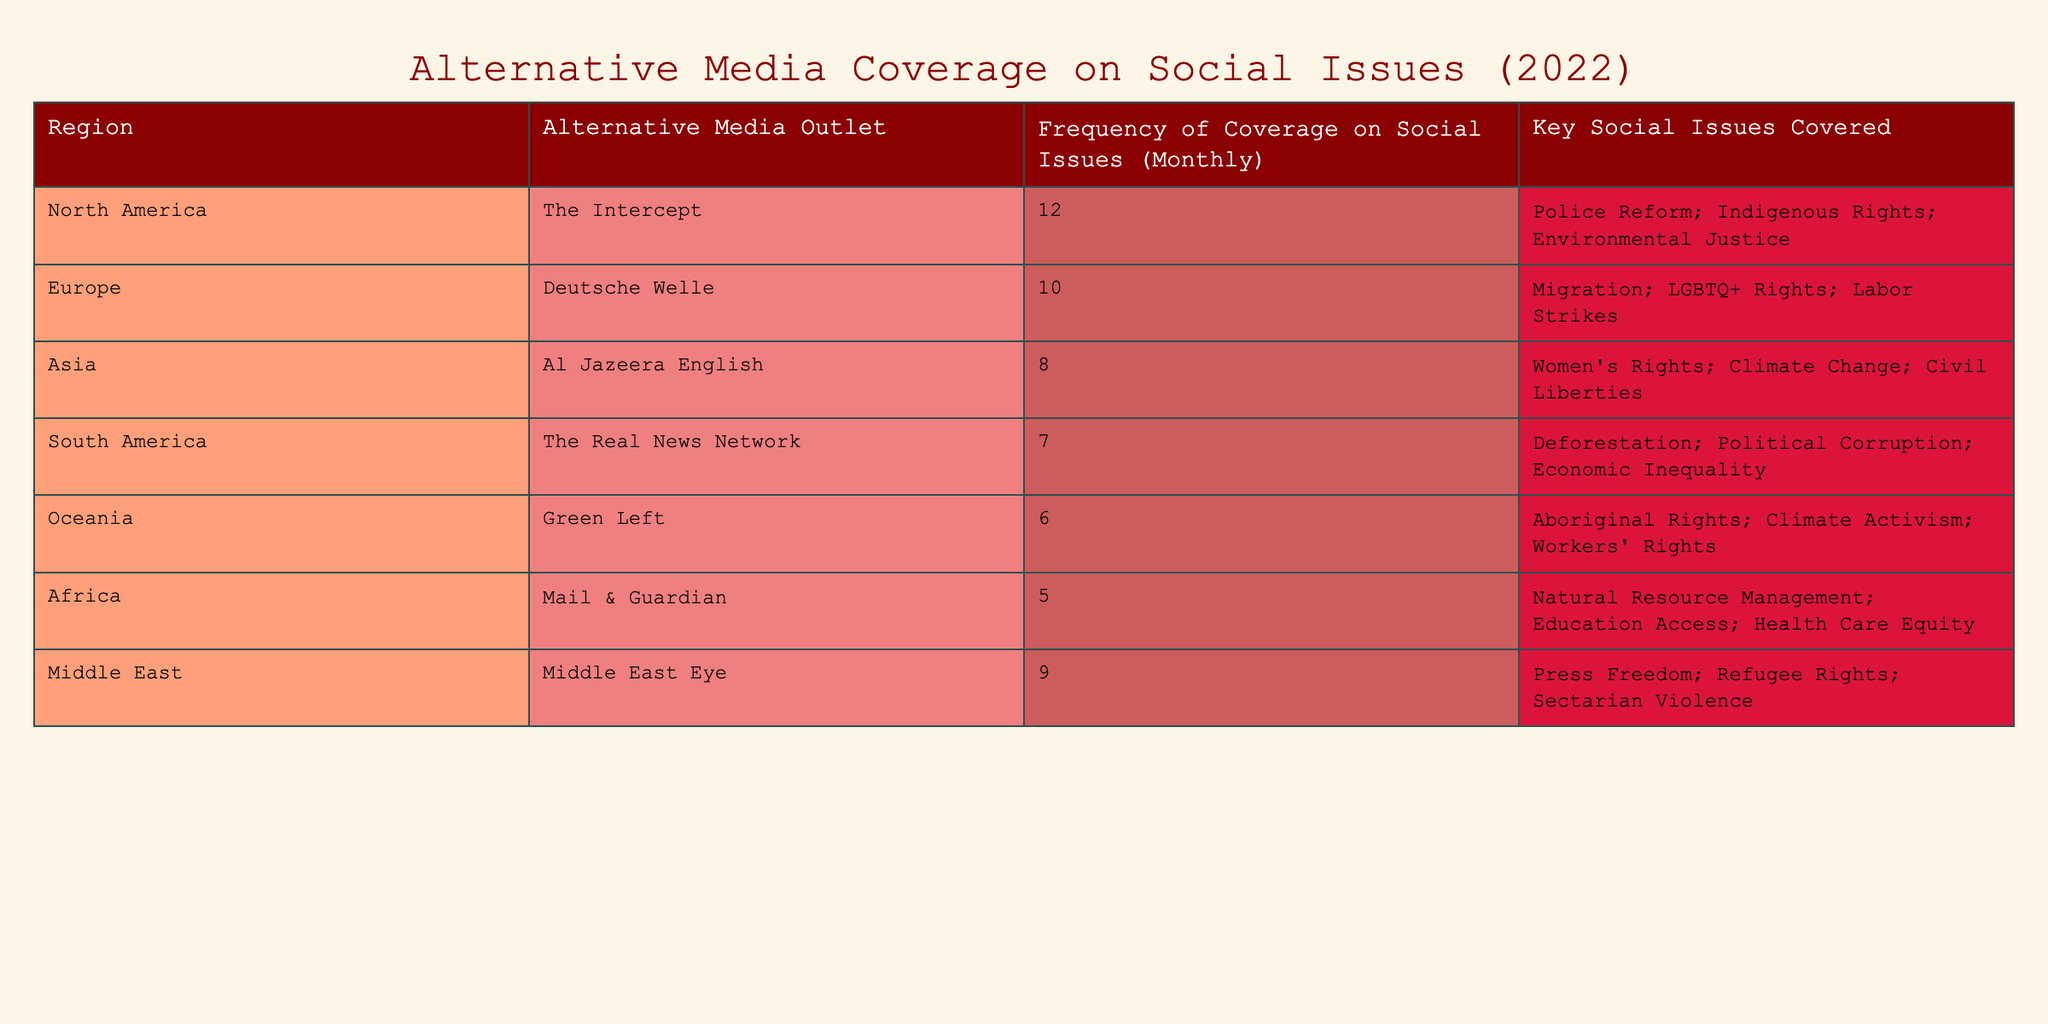What region has the highest frequency of alternative media coverage on social issues? North America has the highest frequency with 12 monthly coverage.
Answer: North America What are the key social issues covered by Deutsche Welle? The key social issues covered by Deutsche Welle include Migration, LGBTQ+ Rights, and Labor Strikes, as stated in the table.
Answer: Migration, LGBTQ+ Rights, Labor Strikes Which region has the lowest frequency of alternative media coverage? Africa has the lowest frequency with a coverage of 5 monthly.
Answer: Africa What is the total frequency of alternative media coverage across all regions? The total frequency can be found by adding the coverage values: 12 + 10 + 8 + 7 + 6 + 5 + 9 = 57.
Answer: 57 Which region covers issues related to women's rights? Asia, as represented by Al Jazeera English, covers women's rights among other issues.
Answer: Asia Is the frequency of coverage for Middle East higher than that of Oceania? Yes, the Middle East has a coverage frequency of 9, while Oceania has 6, making it higher.
Answer: Yes What is the average frequency of coverage for all the listed regions? To find the average, sum the frequencies (57) and divide by the number of regions (7), which results in an average of 57 / 7 = approximately 8.14.
Answer: Approximately 8.14 Which alternative media outlet covers issues related to Aboriginal Rights? Green Left covers issues related to Aboriginal Rights, as noted in the table.
Answer: Green Left How many regions cover climate-related social issues? Four regions cover climate-related social issues: Asia, South America, Oceania, and the Middle East.
Answer: Four Is there a region that does not cover any social issues related to education? Yes, all listed regions except Africa mention educational social issues, therefore the answer is no.
Answer: Yes 